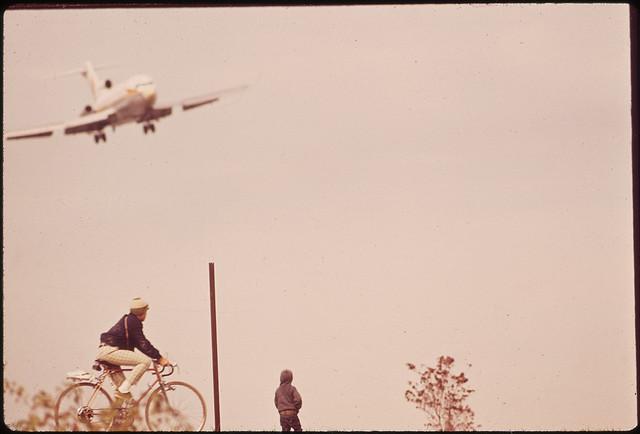How many people are there?
Short answer required. 2. How many animals are shown?
Concise answer only. 0. Is the plane going to land?
Answer briefly. Yes. Is the plane falling?
Write a very short answer. No. How many wheels can be seen in this picture?
Keep it brief. 6. 